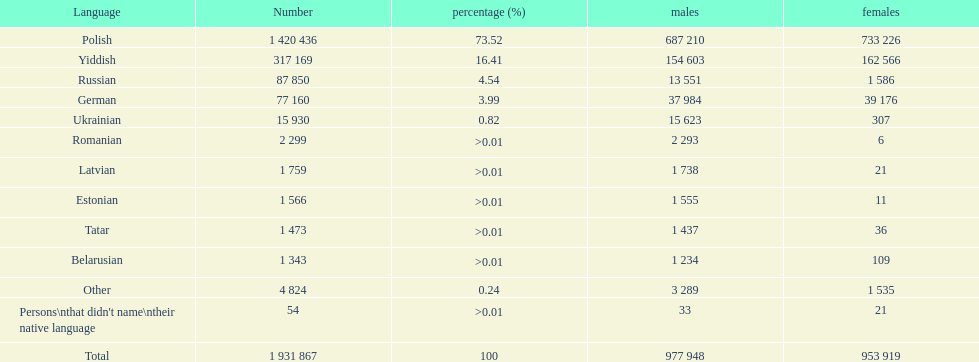Which language had the fewest female speakers? Romanian. 